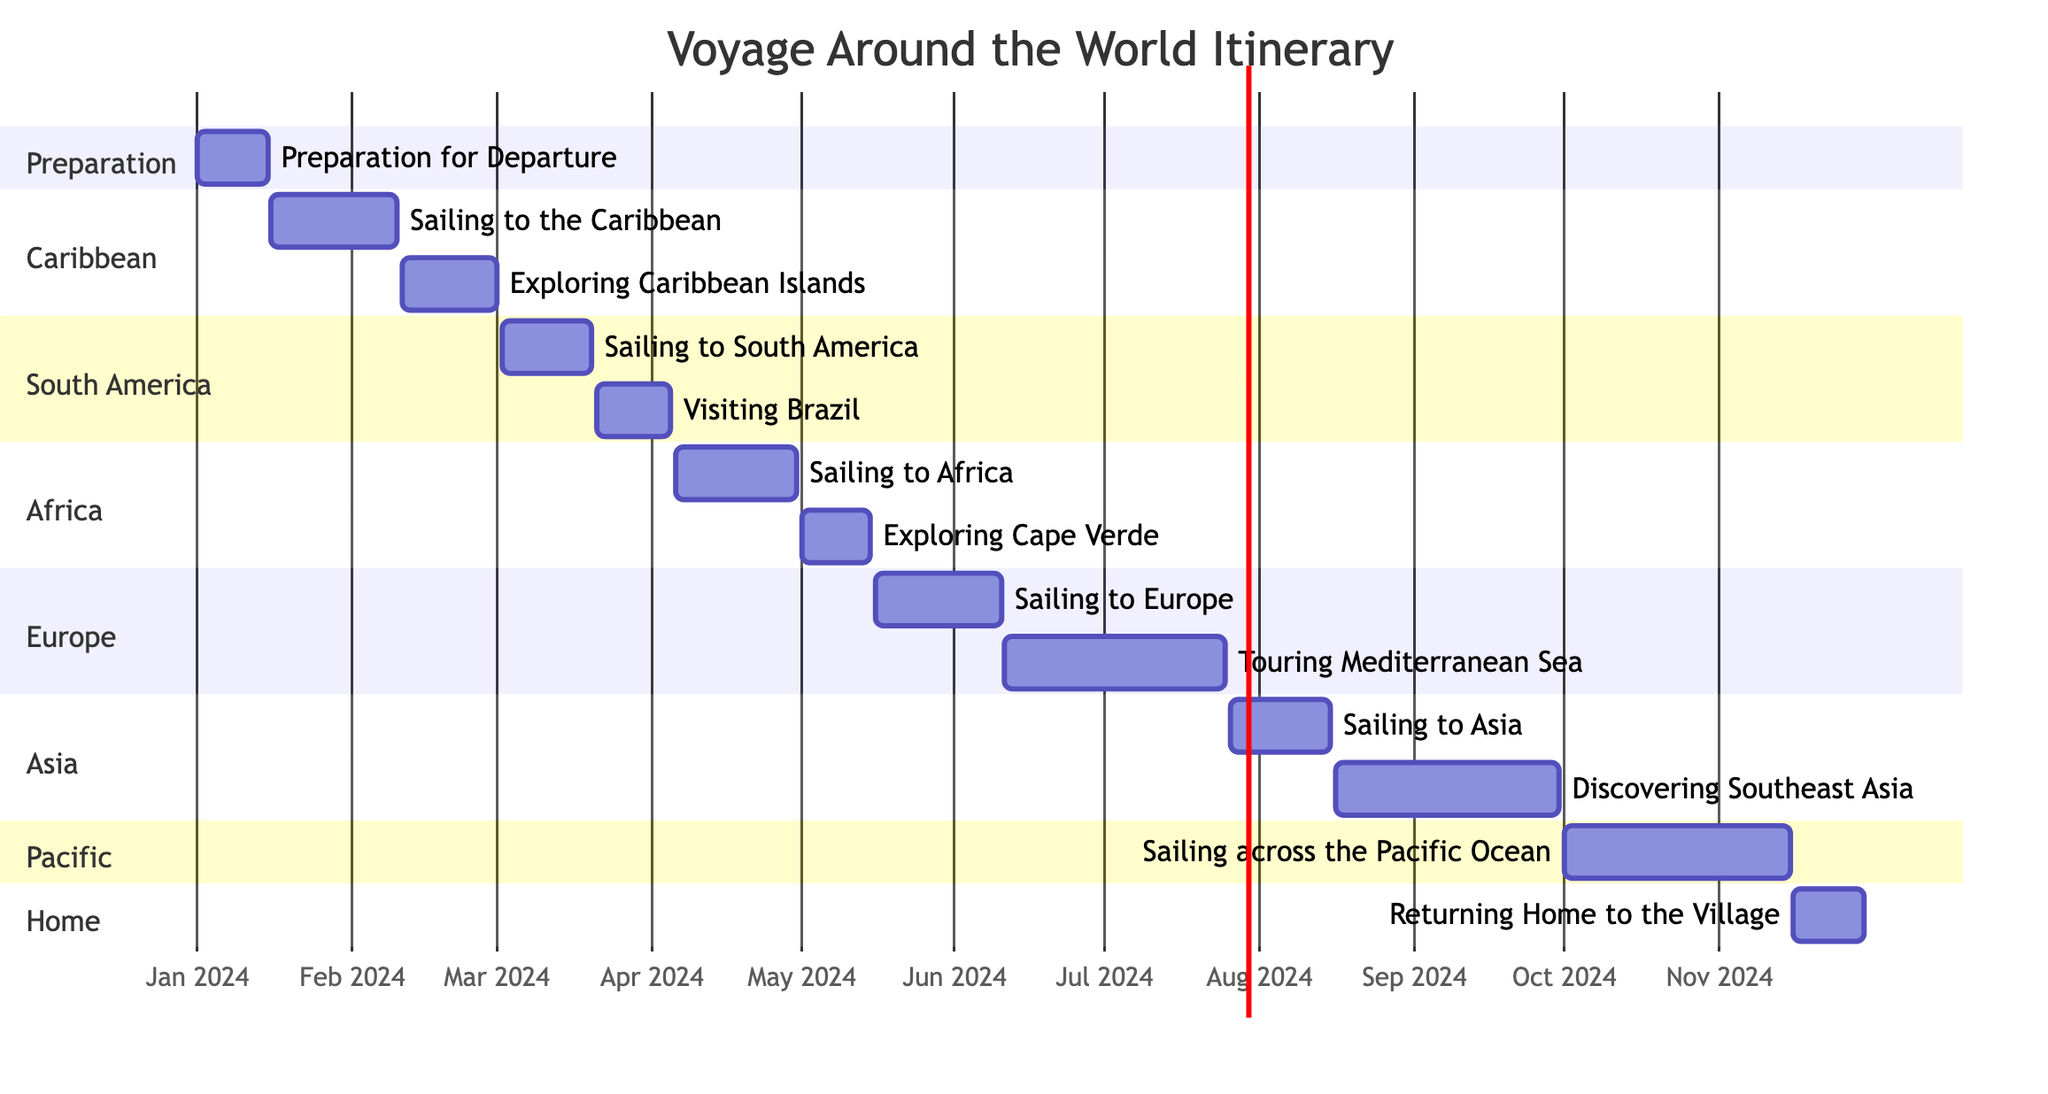What is the total number of tasks in the itinerary? By counting each task listed in the diagram, there are 14 distinct activities that constitute the voyage itinerary.
Answer: 14 What is the start date of "Sailing to Africa"? The start date for "Sailing to Africa" can be found directly in the timeline, indicated as April 6, 2024.
Answer: April 6, 2024 Which task follows "Exploring Cape Verde"? The task that follows "Exploring Cape Verde" is "Sailing to Europe" as seen in the order of tasks on the Gantt chart.
Answer: Sailing to Europe How long is the journey from "Sailing to Asia" to "Discovering Southeast Asia"? The duration between "Sailing to Asia" (from July 26, 2024) and "Discovering Southeast Asia" (starting August 16, 2024) is 21 days based on the timeline.
Answer: 21 days What is the duration of the entire voyage? By examining the start date of the first task (January 1, 2024) and the end date of the last task (November 30, 2024), the total duration of the voyage is calculated to be 11 months.
Answer: 11 months Which section contains the most tasks? By reviewing the sections, the "Caribbean" section has the most tasks, as it includes two: "Sailing to the Caribbean" and "Exploring Caribbean Islands."
Answer: Caribbean What is the end date of "Returning Home to the Village"? The end date for "Returning Home to the Village" is provided directly in the diagram as November 30, 2024.
Answer: November 30, 2024 How many sections are there in the Gantt chart? The sections in the Gantt chart total to 7, identified as Preparation, Caribbean, South America, Africa, Europe, Asia, and Pacific.
Answer: 7 Which task is the very first in the itinerary? The first task in the itinerary, as shown in the Gantt chart, is "Preparation for Departure," starting on January 1, 2024.
Answer: Preparation for Departure 